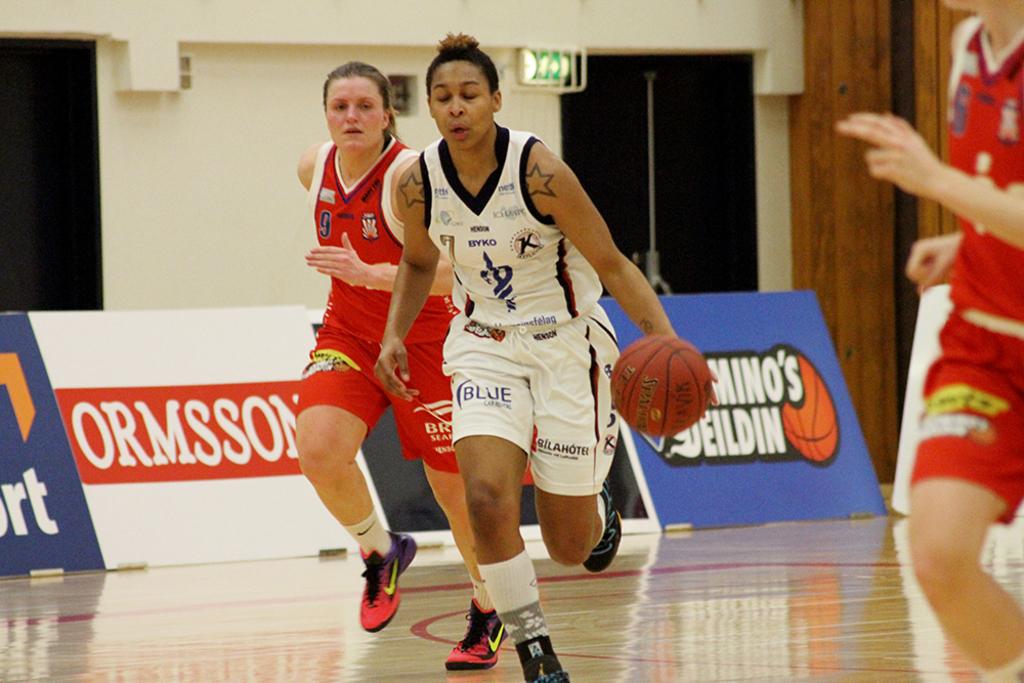What kind of sponsors do the teams have?
Make the answer very short. Unanswerable. What number is red?
Your answer should be very brief. 9. 